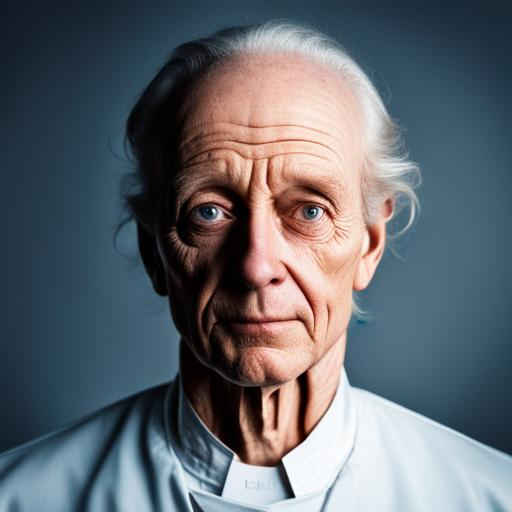Can you comment on the attire of the person in the image? The individual is dressed in a formal, collared garment that resembles a clergyman's attire, signifying a refined and respectable demeanor. 